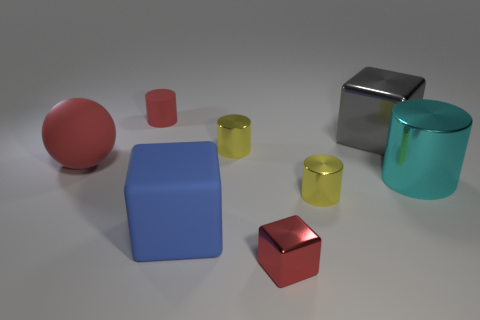There is a tiny red thing that is the same material as the large blue cube; what is its shape?
Provide a succinct answer. Cylinder. Are there any other things of the same color as the large matte block?
Offer a very short reply. No. What is the material of the large block in front of the yellow cylinder behind the big cyan thing?
Keep it short and to the point. Rubber. Is there a small green object that has the same shape as the tiny red shiny object?
Provide a short and direct response. No. How many other objects are there of the same shape as the gray thing?
Ensure brevity in your answer.  2. What is the shape of the small object that is both behind the big matte ball and to the right of the tiny rubber object?
Offer a very short reply. Cylinder. There is a block in front of the large blue object; how big is it?
Your answer should be compact. Small. Do the gray metallic object and the red matte ball have the same size?
Your answer should be very brief. Yes. Is the number of red matte spheres that are behind the tiny red cylinder less than the number of blue things in front of the matte block?
Keep it short and to the point. No. How big is the cube that is both in front of the red sphere and behind the tiny shiny cube?
Provide a succinct answer. Large. 